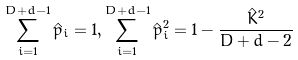<formula> <loc_0><loc_0><loc_500><loc_500>\sum _ { i = 1 } ^ { D + d - 1 } \hat { p } _ { i } = 1 , \sum _ { i = 1 } ^ { D + d - 1 } \hat { p } _ { i } ^ { 2 } = 1 - \frac { \hat { K } ^ { 2 } } { D + d - 2 }</formula> 